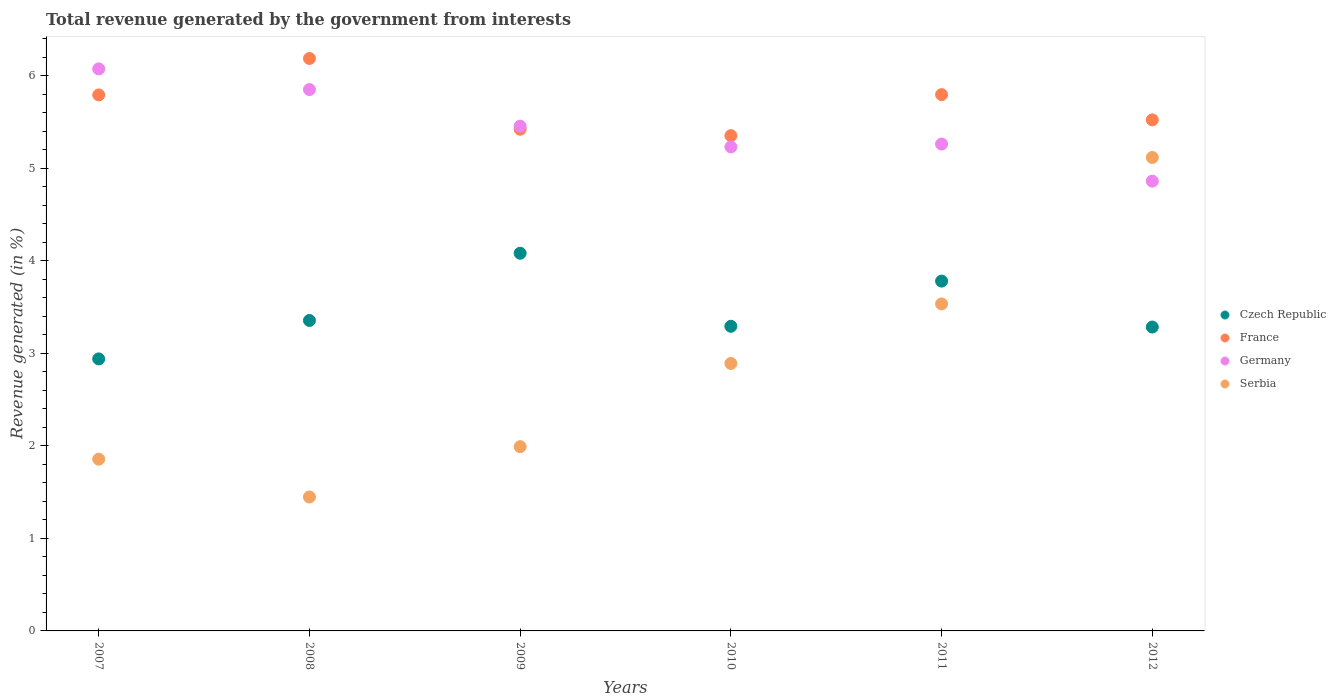How many different coloured dotlines are there?
Your answer should be very brief. 4. What is the total revenue generated in Czech Republic in 2010?
Offer a very short reply. 3.29. Across all years, what is the maximum total revenue generated in Germany?
Your response must be concise. 6.07. Across all years, what is the minimum total revenue generated in Czech Republic?
Your answer should be very brief. 2.94. In which year was the total revenue generated in Serbia maximum?
Your answer should be very brief. 2012. In which year was the total revenue generated in Serbia minimum?
Offer a terse response. 2008. What is the total total revenue generated in Serbia in the graph?
Offer a very short reply. 16.83. What is the difference between the total revenue generated in Germany in 2009 and that in 2011?
Your answer should be compact. 0.19. What is the difference between the total revenue generated in Germany in 2008 and the total revenue generated in Serbia in 2010?
Your answer should be very brief. 2.96. What is the average total revenue generated in Czech Republic per year?
Provide a short and direct response. 3.45. In the year 2009, what is the difference between the total revenue generated in Serbia and total revenue generated in France?
Keep it short and to the point. -3.43. In how many years, is the total revenue generated in Serbia greater than 2.8 %?
Offer a terse response. 3. What is the ratio of the total revenue generated in Germany in 2010 to that in 2012?
Your answer should be very brief. 1.08. What is the difference between the highest and the second highest total revenue generated in Serbia?
Provide a succinct answer. 1.58. What is the difference between the highest and the lowest total revenue generated in Czech Republic?
Offer a very short reply. 1.14. Is the sum of the total revenue generated in Czech Republic in 2008 and 2011 greater than the maximum total revenue generated in Germany across all years?
Your answer should be very brief. Yes. Is it the case that in every year, the sum of the total revenue generated in Germany and total revenue generated in Czech Republic  is greater than the total revenue generated in Serbia?
Offer a very short reply. Yes. Does the total revenue generated in France monotonically increase over the years?
Keep it short and to the point. No. Is the total revenue generated in Czech Republic strictly greater than the total revenue generated in France over the years?
Make the answer very short. No. How many years are there in the graph?
Provide a succinct answer. 6. What is the difference between two consecutive major ticks on the Y-axis?
Make the answer very short. 1. Are the values on the major ticks of Y-axis written in scientific E-notation?
Your answer should be compact. No. Where does the legend appear in the graph?
Your response must be concise. Center right. How many legend labels are there?
Your answer should be very brief. 4. What is the title of the graph?
Make the answer very short. Total revenue generated by the government from interests. Does "Paraguay" appear as one of the legend labels in the graph?
Your answer should be very brief. No. What is the label or title of the X-axis?
Provide a short and direct response. Years. What is the label or title of the Y-axis?
Ensure brevity in your answer.  Revenue generated (in %). What is the Revenue generated (in %) of Czech Republic in 2007?
Ensure brevity in your answer.  2.94. What is the Revenue generated (in %) in France in 2007?
Your response must be concise. 5.79. What is the Revenue generated (in %) in Germany in 2007?
Your response must be concise. 6.07. What is the Revenue generated (in %) of Serbia in 2007?
Give a very brief answer. 1.86. What is the Revenue generated (in %) in Czech Republic in 2008?
Ensure brevity in your answer.  3.35. What is the Revenue generated (in %) in France in 2008?
Your answer should be very brief. 6.18. What is the Revenue generated (in %) in Germany in 2008?
Your answer should be very brief. 5.85. What is the Revenue generated (in %) of Serbia in 2008?
Offer a very short reply. 1.45. What is the Revenue generated (in %) of Czech Republic in 2009?
Make the answer very short. 4.08. What is the Revenue generated (in %) of France in 2009?
Give a very brief answer. 5.42. What is the Revenue generated (in %) of Germany in 2009?
Offer a terse response. 5.45. What is the Revenue generated (in %) in Serbia in 2009?
Provide a succinct answer. 1.99. What is the Revenue generated (in %) of Czech Republic in 2010?
Offer a very short reply. 3.29. What is the Revenue generated (in %) of France in 2010?
Ensure brevity in your answer.  5.35. What is the Revenue generated (in %) in Germany in 2010?
Make the answer very short. 5.23. What is the Revenue generated (in %) in Serbia in 2010?
Ensure brevity in your answer.  2.89. What is the Revenue generated (in %) in Czech Republic in 2011?
Your response must be concise. 3.78. What is the Revenue generated (in %) in France in 2011?
Ensure brevity in your answer.  5.79. What is the Revenue generated (in %) of Germany in 2011?
Your response must be concise. 5.26. What is the Revenue generated (in %) in Serbia in 2011?
Ensure brevity in your answer.  3.53. What is the Revenue generated (in %) of Czech Republic in 2012?
Your answer should be compact. 3.28. What is the Revenue generated (in %) in France in 2012?
Your answer should be very brief. 5.52. What is the Revenue generated (in %) of Germany in 2012?
Make the answer very short. 4.86. What is the Revenue generated (in %) of Serbia in 2012?
Ensure brevity in your answer.  5.12. Across all years, what is the maximum Revenue generated (in %) in Czech Republic?
Ensure brevity in your answer.  4.08. Across all years, what is the maximum Revenue generated (in %) in France?
Give a very brief answer. 6.18. Across all years, what is the maximum Revenue generated (in %) of Germany?
Keep it short and to the point. 6.07. Across all years, what is the maximum Revenue generated (in %) in Serbia?
Provide a short and direct response. 5.12. Across all years, what is the minimum Revenue generated (in %) of Czech Republic?
Ensure brevity in your answer.  2.94. Across all years, what is the minimum Revenue generated (in %) in France?
Provide a succinct answer. 5.35. Across all years, what is the minimum Revenue generated (in %) of Germany?
Your answer should be very brief. 4.86. Across all years, what is the minimum Revenue generated (in %) of Serbia?
Keep it short and to the point. 1.45. What is the total Revenue generated (in %) of Czech Republic in the graph?
Your response must be concise. 20.73. What is the total Revenue generated (in %) of France in the graph?
Offer a very short reply. 34.06. What is the total Revenue generated (in %) of Germany in the graph?
Make the answer very short. 32.72. What is the total Revenue generated (in %) of Serbia in the graph?
Make the answer very short. 16.83. What is the difference between the Revenue generated (in %) in Czech Republic in 2007 and that in 2008?
Provide a short and direct response. -0.42. What is the difference between the Revenue generated (in %) of France in 2007 and that in 2008?
Keep it short and to the point. -0.39. What is the difference between the Revenue generated (in %) in Germany in 2007 and that in 2008?
Your response must be concise. 0.22. What is the difference between the Revenue generated (in %) of Serbia in 2007 and that in 2008?
Offer a very short reply. 0.41. What is the difference between the Revenue generated (in %) in Czech Republic in 2007 and that in 2009?
Your answer should be compact. -1.14. What is the difference between the Revenue generated (in %) of France in 2007 and that in 2009?
Your response must be concise. 0.37. What is the difference between the Revenue generated (in %) of Germany in 2007 and that in 2009?
Ensure brevity in your answer.  0.62. What is the difference between the Revenue generated (in %) of Serbia in 2007 and that in 2009?
Make the answer very short. -0.14. What is the difference between the Revenue generated (in %) in Czech Republic in 2007 and that in 2010?
Keep it short and to the point. -0.35. What is the difference between the Revenue generated (in %) of France in 2007 and that in 2010?
Your answer should be very brief. 0.44. What is the difference between the Revenue generated (in %) in Germany in 2007 and that in 2010?
Make the answer very short. 0.84. What is the difference between the Revenue generated (in %) in Serbia in 2007 and that in 2010?
Give a very brief answer. -1.03. What is the difference between the Revenue generated (in %) in Czech Republic in 2007 and that in 2011?
Offer a very short reply. -0.84. What is the difference between the Revenue generated (in %) in France in 2007 and that in 2011?
Give a very brief answer. -0. What is the difference between the Revenue generated (in %) in Germany in 2007 and that in 2011?
Make the answer very short. 0.81. What is the difference between the Revenue generated (in %) in Serbia in 2007 and that in 2011?
Make the answer very short. -1.68. What is the difference between the Revenue generated (in %) in Czech Republic in 2007 and that in 2012?
Offer a very short reply. -0.34. What is the difference between the Revenue generated (in %) of France in 2007 and that in 2012?
Offer a very short reply. 0.27. What is the difference between the Revenue generated (in %) of Germany in 2007 and that in 2012?
Make the answer very short. 1.21. What is the difference between the Revenue generated (in %) of Serbia in 2007 and that in 2012?
Make the answer very short. -3.26. What is the difference between the Revenue generated (in %) in Czech Republic in 2008 and that in 2009?
Offer a terse response. -0.73. What is the difference between the Revenue generated (in %) in France in 2008 and that in 2009?
Ensure brevity in your answer.  0.76. What is the difference between the Revenue generated (in %) of Germany in 2008 and that in 2009?
Your response must be concise. 0.4. What is the difference between the Revenue generated (in %) in Serbia in 2008 and that in 2009?
Keep it short and to the point. -0.54. What is the difference between the Revenue generated (in %) of Czech Republic in 2008 and that in 2010?
Your response must be concise. 0.06. What is the difference between the Revenue generated (in %) of France in 2008 and that in 2010?
Keep it short and to the point. 0.83. What is the difference between the Revenue generated (in %) in Germany in 2008 and that in 2010?
Offer a very short reply. 0.62. What is the difference between the Revenue generated (in %) of Serbia in 2008 and that in 2010?
Ensure brevity in your answer.  -1.44. What is the difference between the Revenue generated (in %) of Czech Republic in 2008 and that in 2011?
Give a very brief answer. -0.43. What is the difference between the Revenue generated (in %) in France in 2008 and that in 2011?
Give a very brief answer. 0.39. What is the difference between the Revenue generated (in %) of Germany in 2008 and that in 2011?
Ensure brevity in your answer.  0.59. What is the difference between the Revenue generated (in %) in Serbia in 2008 and that in 2011?
Your response must be concise. -2.09. What is the difference between the Revenue generated (in %) of Czech Republic in 2008 and that in 2012?
Offer a very short reply. 0.07. What is the difference between the Revenue generated (in %) in France in 2008 and that in 2012?
Give a very brief answer. 0.66. What is the difference between the Revenue generated (in %) of Germany in 2008 and that in 2012?
Offer a terse response. 0.99. What is the difference between the Revenue generated (in %) of Serbia in 2008 and that in 2012?
Provide a succinct answer. -3.67. What is the difference between the Revenue generated (in %) of Czech Republic in 2009 and that in 2010?
Keep it short and to the point. 0.79. What is the difference between the Revenue generated (in %) of France in 2009 and that in 2010?
Your answer should be compact. 0.07. What is the difference between the Revenue generated (in %) of Germany in 2009 and that in 2010?
Keep it short and to the point. 0.22. What is the difference between the Revenue generated (in %) of Serbia in 2009 and that in 2010?
Give a very brief answer. -0.9. What is the difference between the Revenue generated (in %) of Czech Republic in 2009 and that in 2011?
Provide a succinct answer. 0.3. What is the difference between the Revenue generated (in %) in France in 2009 and that in 2011?
Keep it short and to the point. -0.37. What is the difference between the Revenue generated (in %) in Germany in 2009 and that in 2011?
Provide a short and direct response. 0.19. What is the difference between the Revenue generated (in %) in Serbia in 2009 and that in 2011?
Your answer should be compact. -1.54. What is the difference between the Revenue generated (in %) of Czech Republic in 2009 and that in 2012?
Provide a succinct answer. 0.8. What is the difference between the Revenue generated (in %) in France in 2009 and that in 2012?
Your answer should be compact. -0.1. What is the difference between the Revenue generated (in %) in Germany in 2009 and that in 2012?
Your answer should be very brief. 0.59. What is the difference between the Revenue generated (in %) in Serbia in 2009 and that in 2012?
Your response must be concise. -3.12. What is the difference between the Revenue generated (in %) of Czech Republic in 2010 and that in 2011?
Your answer should be compact. -0.49. What is the difference between the Revenue generated (in %) of France in 2010 and that in 2011?
Offer a terse response. -0.44. What is the difference between the Revenue generated (in %) of Germany in 2010 and that in 2011?
Ensure brevity in your answer.  -0.03. What is the difference between the Revenue generated (in %) of Serbia in 2010 and that in 2011?
Offer a very short reply. -0.64. What is the difference between the Revenue generated (in %) in Czech Republic in 2010 and that in 2012?
Make the answer very short. 0.01. What is the difference between the Revenue generated (in %) of France in 2010 and that in 2012?
Provide a succinct answer. -0.17. What is the difference between the Revenue generated (in %) of Germany in 2010 and that in 2012?
Give a very brief answer. 0.37. What is the difference between the Revenue generated (in %) of Serbia in 2010 and that in 2012?
Your response must be concise. -2.23. What is the difference between the Revenue generated (in %) in Czech Republic in 2011 and that in 2012?
Your response must be concise. 0.5. What is the difference between the Revenue generated (in %) of France in 2011 and that in 2012?
Give a very brief answer. 0.27. What is the difference between the Revenue generated (in %) in Germany in 2011 and that in 2012?
Provide a succinct answer. 0.4. What is the difference between the Revenue generated (in %) of Serbia in 2011 and that in 2012?
Provide a short and direct response. -1.58. What is the difference between the Revenue generated (in %) of Czech Republic in 2007 and the Revenue generated (in %) of France in 2008?
Offer a very short reply. -3.25. What is the difference between the Revenue generated (in %) of Czech Republic in 2007 and the Revenue generated (in %) of Germany in 2008?
Provide a short and direct response. -2.91. What is the difference between the Revenue generated (in %) of Czech Republic in 2007 and the Revenue generated (in %) of Serbia in 2008?
Make the answer very short. 1.49. What is the difference between the Revenue generated (in %) in France in 2007 and the Revenue generated (in %) in Germany in 2008?
Give a very brief answer. -0.06. What is the difference between the Revenue generated (in %) in France in 2007 and the Revenue generated (in %) in Serbia in 2008?
Make the answer very short. 4.34. What is the difference between the Revenue generated (in %) of Germany in 2007 and the Revenue generated (in %) of Serbia in 2008?
Provide a succinct answer. 4.63. What is the difference between the Revenue generated (in %) in Czech Republic in 2007 and the Revenue generated (in %) in France in 2009?
Your response must be concise. -2.48. What is the difference between the Revenue generated (in %) of Czech Republic in 2007 and the Revenue generated (in %) of Germany in 2009?
Make the answer very short. -2.51. What is the difference between the Revenue generated (in %) in Czech Republic in 2007 and the Revenue generated (in %) in Serbia in 2009?
Provide a short and direct response. 0.95. What is the difference between the Revenue generated (in %) of France in 2007 and the Revenue generated (in %) of Germany in 2009?
Give a very brief answer. 0.34. What is the difference between the Revenue generated (in %) of France in 2007 and the Revenue generated (in %) of Serbia in 2009?
Keep it short and to the point. 3.8. What is the difference between the Revenue generated (in %) in Germany in 2007 and the Revenue generated (in %) in Serbia in 2009?
Make the answer very short. 4.08. What is the difference between the Revenue generated (in %) in Czech Republic in 2007 and the Revenue generated (in %) in France in 2010?
Give a very brief answer. -2.41. What is the difference between the Revenue generated (in %) of Czech Republic in 2007 and the Revenue generated (in %) of Germany in 2010?
Your answer should be very brief. -2.29. What is the difference between the Revenue generated (in %) of Czech Republic in 2007 and the Revenue generated (in %) of Serbia in 2010?
Keep it short and to the point. 0.05. What is the difference between the Revenue generated (in %) in France in 2007 and the Revenue generated (in %) in Germany in 2010?
Your answer should be compact. 0.56. What is the difference between the Revenue generated (in %) of France in 2007 and the Revenue generated (in %) of Serbia in 2010?
Give a very brief answer. 2.9. What is the difference between the Revenue generated (in %) of Germany in 2007 and the Revenue generated (in %) of Serbia in 2010?
Your answer should be compact. 3.18. What is the difference between the Revenue generated (in %) of Czech Republic in 2007 and the Revenue generated (in %) of France in 2011?
Offer a terse response. -2.86. What is the difference between the Revenue generated (in %) in Czech Republic in 2007 and the Revenue generated (in %) in Germany in 2011?
Keep it short and to the point. -2.32. What is the difference between the Revenue generated (in %) in Czech Republic in 2007 and the Revenue generated (in %) in Serbia in 2011?
Make the answer very short. -0.59. What is the difference between the Revenue generated (in %) of France in 2007 and the Revenue generated (in %) of Germany in 2011?
Make the answer very short. 0.53. What is the difference between the Revenue generated (in %) of France in 2007 and the Revenue generated (in %) of Serbia in 2011?
Provide a succinct answer. 2.26. What is the difference between the Revenue generated (in %) of Germany in 2007 and the Revenue generated (in %) of Serbia in 2011?
Keep it short and to the point. 2.54. What is the difference between the Revenue generated (in %) in Czech Republic in 2007 and the Revenue generated (in %) in France in 2012?
Provide a short and direct response. -2.58. What is the difference between the Revenue generated (in %) in Czech Republic in 2007 and the Revenue generated (in %) in Germany in 2012?
Give a very brief answer. -1.92. What is the difference between the Revenue generated (in %) of Czech Republic in 2007 and the Revenue generated (in %) of Serbia in 2012?
Your response must be concise. -2.18. What is the difference between the Revenue generated (in %) of France in 2007 and the Revenue generated (in %) of Germany in 2012?
Keep it short and to the point. 0.93. What is the difference between the Revenue generated (in %) in France in 2007 and the Revenue generated (in %) in Serbia in 2012?
Ensure brevity in your answer.  0.68. What is the difference between the Revenue generated (in %) of Germany in 2007 and the Revenue generated (in %) of Serbia in 2012?
Ensure brevity in your answer.  0.96. What is the difference between the Revenue generated (in %) in Czech Republic in 2008 and the Revenue generated (in %) in France in 2009?
Ensure brevity in your answer.  -2.07. What is the difference between the Revenue generated (in %) in Czech Republic in 2008 and the Revenue generated (in %) in Germany in 2009?
Make the answer very short. -2.1. What is the difference between the Revenue generated (in %) in Czech Republic in 2008 and the Revenue generated (in %) in Serbia in 2009?
Keep it short and to the point. 1.36. What is the difference between the Revenue generated (in %) of France in 2008 and the Revenue generated (in %) of Germany in 2009?
Your answer should be very brief. 0.73. What is the difference between the Revenue generated (in %) in France in 2008 and the Revenue generated (in %) in Serbia in 2009?
Provide a succinct answer. 4.19. What is the difference between the Revenue generated (in %) of Germany in 2008 and the Revenue generated (in %) of Serbia in 2009?
Give a very brief answer. 3.86. What is the difference between the Revenue generated (in %) of Czech Republic in 2008 and the Revenue generated (in %) of France in 2010?
Provide a succinct answer. -2. What is the difference between the Revenue generated (in %) in Czech Republic in 2008 and the Revenue generated (in %) in Germany in 2010?
Your answer should be very brief. -1.88. What is the difference between the Revenue generated (in %) in Czech Republic in 2008 and the Revenue generated (in %) in Serbia in 2010?
Make the answer very short. 0.46. What is the difference between the Revenue generated (in %) in France in 2008 and the Revenue generated (in %) in Germany in 2010?
Your answer should be compact. 0.96. What is the difference between the Revenue generated (in %) in France in 2008 and the Revenue generated (in %) in Serbia in 2010?
Your answer should be compact. 3.29. What is the difference between the Revenue generated (in %) of Germany in 2008 and the Revenue generated (in %) of Serbia in 2010?
Keep it short and to the point. 2.96. What is the difference between the Revenue generated (in %) in Czech Republic in 2008 and the Revenue generated (in %) in France in 2011?
Ensure brevity in your answer.  -2.44. What is the difference between the Revenue generated (in %) of Czech Republic in 2008 and the Revenue generated (in %) of Germany in 2011?
Keep it short and to the point. -1.91. What is the difference between the Revenue generated (in %) of Czech Republic in 2008 and the Revenue generated (in %) of Serbia in 2011?
Offer a very short reply. -0.18. What is the difference between the Revenue generated (in %) in France in 2008 and the Revenue generated (in %) in Germany in 2011?
Your response must be concise. 0.92. What is the difference between the Revenue generated (in %) in France in 2008 and the Revenue generated (in %) in Serbia in 2011?
Offer a very short reply. 2.65. What is the difference between the Revenue generated (in %) in Germany in 2008 and the Revenue generated (in %) in Serbia in 2011?
Provide a succinct answer. 2.32. What is the difference between the Revenue generated (in %) of Czech Republic in 2008 and the Revenue generated (in %) of France in 2012?
Provide a succinct answer. -2.17. What is the difference between the Revenue generated (in %) of Czech Republic in 2008 and the Revenue generated (in %) of Germany in 2012?
Your answer should be very brief. -1.51. What is the difference between the Revenue generated (in %) of Czech Republic in 2008 and the Revenue generated (in %) of Serbia in 2012?
Make the answer very short. -1.76. What is the difference between the Revenue generated (in %) in France in 2008 and the Revenue generated (in %) in Germany in 2012?
Provide a short and direct response. 1.33. What is the difference between the Revenue generated (in %) in France in 2008 and the Revenue generated (in %) in Serbia in 2012?
Your answer should be compact. 1.07. What is the difference between the Revenue generated (in %) of Germany in 2008 and the Revenue generated (in %) of Serbia in 2012?
Your answer should be very brief. 0.73. What is the difference between the Revenue generated (in %) of Czech Republic in 2009 and the Revenue generated (in %) of France in 2010?
Your answer should be very brief. -1.27. What is the difference between the Revenue generated (in %) of Czech Republic in 2009 and the Revenue generated (in %) of Germany in 2010?
Your answer should be very brief. -1.15. What is the difference between the Revenue generated (in %) in Czech Republic in 2009 and the Revenue generated (in %) in Serbia in 2010?
Your response must be concise. 1.19. What is the difference between the Revenue generated (in %) in France in 2009 and the Revenue generated (in %) in Germany in 2010?
Your answer should be very brief. 0.19. What is the difference between the Revenue generated (in %) of France in 2009 and the Revenue generated (in %) of Serbia in 2010?
Give a very brief answer. 2.53. What is the difference between the Revenue generated (in %) in Germany in 2009 and the Revenue generated (in %) in Serbia in 2010?
Make the answer very short. 2.56. What is the difference between the Revenue generated (in %) of Czech Republic in 2009 and the Revenue generated (in %) of France in 2011?
Make the answer very short. -1.71. What is the difference between the Revenue generated (in %) of Czech Republic in 2009 and the Revenue generated (in %) of Germany in 2011?
Provide a succinct answer. -1.18. What is the difference between the Revenue generated (in %) in Czech Republic in 2009 and the Revenue generated (in %) in Serbia in 2011?
Your answer should be very brief. 0.55. What is the difference between the Revenue generated (in %) in France in 2009 and the Revenue generated (in %) in Germany in 2011?
Provide a succinct answer. 0.16. What is the difference between the Revenue generated (in %) of France in 2009 and the Revenue generated (in %) of Serbia in 2011?
Ensure brevity in your answer.  1.89. What is the difference between the Revenue generated (in %) of Germany in 2009 and the Revenue generated (in %) of Serbia in 2011?
Keep it short and to the point. 1.92. What is the difference between the Revenue generated (in %) of Czech Republic in 2009 and the Revenue generated (in %) of France in 2012?
Your answer should be compact. -1.44. What is the difference between the Revenue generated (in %) in Czech Republic in 2009 and the Revenue generated (in %) in Germany in 2012?
Provide a succinct answer. -0.78. What is the difference between the Revenue generated (in %) of Czech Republic in 2009 and the Revenue generated (in %) of Serbia in 2012?
Provide a short and direct response. -1.03. What is the difference between the Revenue generated (in %) in France in 2009 and the Revenue generated (in %) in Germany in 2012?
Give a very brief answer. 0.56. What is the difference between the Revenue generated (in %) in France in 2009 and the Revenue generated (in %) in Serbia in 2012?
Offer a terse response. 0.31. What is the difference between the Revenue generated (in %) in Germany in 2009 and the Revenue generated (in %) in Serbia in 2012?
Your response must be concise. 0.34. What is the difference between the Revenue generated (in %) in Czech Republic in 2010 and the Revenue generated (in %) in France in 2011?
Your response must be concise. -2.5. What is the difference between the Revenue generated (in %) of Czech Republic in 2010 and the Revenue generated (in %) of Germany in 2011?
Provide a succinct answer. -1.97. What is the difference between the Revenue generated (in %) in Czech Republic in 2010 and the Revenue generated (in %) in Serbia in 2011?
Keep it short and to the point. -0.24. What is the difference between the Revenue generated (in %) in France in 2010 and the Revenue generated (in %) in Germany in 2011?
Your response must be concise. 0.09. What is the difference between the Revenue generated (in %) of France in 2010 and the Revenue generated (in %) of Serbia in 2011?
Provide a short and direct response. 1.82. What is the difference between the Revenue generated (in %) of Germany in 2010 and the Revenue generated (in %) of Serbia in 2011?
Give a very brief answer. 1.7. What is the difference between the Revenue generated (in %) in Czech Republic in 2010 and the Revenue generated (in %) in France in 2012?
Provide a short and direct response. -2.23. What is the difference between the Revenue generated (in %) in Czech Republic in 2010 and the Revenue generated (in %) in Germany in 2012?
Provide a short and direct response. -1.57. What is the difference between the Revenue generated (in %) in Czech Republic in 2010 and the Revenue generated (in %) in Serbia in 2012?
Provide a succinct answer. -1.82. What is the difference between the Revenue generated (in %) in France in 2010 and the Revenue generated (in %) in Germany in 2012?
Provide a succinct answer. 0.49. What is the difference between the Revenue generated (in %) in France in 2010 and the Revenue generated (in %) in Serbia in 2012?
Your response must be concise. 0.24. What is the difference between the Revenue generated (in %) of Germany in 2010 and the Revenue generated (in %) of Serbia in 2012?
Offer a terse response. 0.11. What is the difference between the Revenue generated (in %) in Czech Republic in 2011 and the Revenue generated (in %) in France in 2012?
Offer a very short reply. -1.74. What is the difference between the Revenue generated (in %) of Czech Republic in 2011 and the Revenue generated (in %) of Germany in 2012?
Your answer should be very brief. -1.08. What is the difference between the Revenue generated (in %) in Czech Republic in 2011 and the Revenue generated (in %) in Serbia in 2012?
Your answer should be compact. -1.34. What is the difference between the Revenue generated (in %) of France in 2011 and the Revenue generated (in %) of Germany in 2012?
Provide a succinct answer. 0.93. What is the difference between the Revenue generated (in %) of France in 2011 and the Revenue generated (in %) of Serbia in 2012?
Offer a very short reply. 0.68. What is the difference between the Revenue generated (in %) of Germany in 2011 and the Revenue generated (in %) of Serbia in 2012?
Your answer should be very brief. 0.14. What is the average Revenue generated (in %) of Czech Republic per year?
Offer a very short reply. 3.45. What is the average Revenue generated (in %) in France per year?
Your response must be concise. 5.68. What is the average Revenue generated (in %) of Germany per year?
Your answer should be compact. 5.45. What is the average Revenue generated (in %) in Serbia per year?
Your answer should be compact. 2.81. In the year 2007, what is the difference between the Revenue generated (in %) in Czech Republic and Revenue generated (in %) in France?
Provide a succinct answer. -2.85. In the year 2007, what is the difference between the Revenue generated (in %) of Czech Republic and Revenue generated (in %) of Germany?
Give a very brief answer. -3.13. In the year 2007, what is the difference between the Revenue generated (in %) of Czech Republic and Revenue generated (in %) of Serbia?
Your response must be concise. 1.08. In the year 2007, what is the difference between the Revenue generated (in %) in France and Revenue generated (in %) in Germany?
Ensure brevity in your answer.  -0.28. In the year 2007, what is the difference between the Revenue generated (in %) of France and Revenue generated (in %) of Serbia?
Provide a short and direct response. 3.94. In the year 2007, what is the difference between the Revenue generated (in %) of Germany and Revenue generated (in %) of Serbia?
Offer a terse response. 4.22. In the year 2008, what is the difference between the Revenue generated (in %) in Czech Republic and Revenue generated (in %) in France?
Offer a terse response. -2.83. In the year 2008, what is the difference between the Revenue generated (in %) of Czech Republic and Revenue generated (in %) of Germany?
Make the answer very short. -2.49. In the year 2008, what is the difference between the Revenue generated (in %) of Czech Republic and Revenue generated (in %) of Serbia?
Make the answer very short. 1.91. In the year 2008, what is the difference between the Revenue generated (in %) of France and Revenue generated (in %) of Germany?
Make the answer very short. 0.34. In the year 2008, what is the difference between the Revenue generated (in %) in France and Revenue generated (in %) in Serbia?
Your answer should be compact. 4.74. In the year 2008, what is the difference between the Revenue generated (in %) in Germany and Revenue generated (in %) in Serbia?
Your answer should be compact. 4.4. In the year 2009, what is the difference between the Revenue generated (in %) of Czech Republic and Revenue generated (in %) of France?
Provide a succinct answer. -1.34. In the year 2009, what is the difference between the Revenue generated (in %) of Czech Republic and Revenue generated (in %) of Germany?
Ensure brevity in your answer.  -1.37. In the year 2009, what is the difference between the Revenue generated (in %) of Czech Republic and Revenue generated (in %) of Serbia?
Your answer should be very brief. 2.09. In the year 2009, what is the difference between the Revenue generated (in %) of France and Revenue generated (in %) of Germany?
Provide a short and direct response. -0.03. In the year 2009, what is the difference between the Revenue generated (in %) of France and Revenue generated (in %) of Serbia?
Your answer should be compact. 3.43. In the year 2009, what is the difference between the Revenue generated (in %) of Germany and Revenue generated (in %) of Serbia?
Provide a succinct answer. 3.46. In the year 2010, what is the difference between the Revenue generated (in %) of Czech Republic and Revenue generated (in %) of France?
Keep it short and to the point. -2.06. In the year 2010, what is the difference between the Revenue generated (in %) in Czech Republic and Revenue generated (in %) in Germany?
Provide a succinct answer. -1.94. In the year 2010, what is the difference between the Revenue generated (in %) in Czech Republic and Revenue generated (in %) in Serbia?
Provide a short and direct response. 0.4. In the year 2010, what is the difference between the Revenue generated (in %) in France and Revenue generated (in %) in Germany?
Keep it short and to the point. 0.12. In the year 2010, what is the difference between the Revenue generated (in %) of France and Revenue generated (in %) of Serbia?
Keep it short and to the point. 2.46. In the year 2010, what is the difference between the Revenue generated (in %) in Germany and Revenue generated (in %) in Serbia?
Provide a short and direct response. 2.34. In the year 2011, what is the difference between the Revenue generated (in %) of Czech Republic and Revenue generated (in %) of France?
Provide a succinct answer. -2.01. In the year 2011, what is the difference between the Revenue generated (in %) in Czech Republic and Revenue generated (in %) in Germany?
Provide a short and direct response. -1.48. In the year 2011, what is the difference between the Revenue generated (in %) of Czech Republic and Revenue generated (in %) of Serbia?
Your response must be concise. 0.25. In the year 2011, what is the difference between the Revenue generated (in %) of France and Revenue generated (in %) of Germany?
Give a very brief answer. 0.53. In the year 2011, what is the difference between the Revenue generated (in %) in France and Revenue generated (in %) in Serbia?
Offer a terse response. 2.26. In the year 2011, what is the difference between the Revenue generated (in %) of Germany and Revenue generated (in %) of Serbia?
Give a very brief answer. 1.73. In the year 2012, what is the difference between the Revenue generated (in %) of Czech Republic and Revenue generated (in %) of France?
Give a very brief answer. -2.24. In the year 2012, what is the difference between the Revenue generated (in %) of Czech Republic and Revenue generated (in %) of Germany?
Offer a terse response. -1.58. In the year 2012, what is the difference between the Revenue generated (in %) in Czech Republic and Revenue generated (in %) in Serbia?
Provide a short and direct response. -1.83. In the year 2012, what is the difference between the Revenue generated (in %) in France and Revenue generated (in %) in Germany?
Offer a terse response. 0.66. In the year 2012, what is the difference between the Revenue generated (in %) of France and Revenue generated (in %) of Serbia?
Keep it short and to the point. 0.41. In the year 2012, what is the difference between the Revenue generated (in %) in Germany and Revenue generated (in %) in Serbia?
Provide a succinct answer. -0.26. What is the ratio of the Revenue generated (in %) in Czech Republic in 2007 to that in 2008?
Your answer should be compact. 0.88. What is the ratio of the Revenue generated (in %) of France in 2007 to that in 2008?
Keep it short and to the point. 0.94. What is the ratio of the Revenue generated (in %) in Germany in 2007 to that in 2008?
Give a very brief answer. 1.04. What is the ratio of the Revenue generated (in %) in Serbia in 2007 to that in 2008?
Your answer should be very brief. 1.28. What is the ratio of the Revenue generated (in %) of Czech Republic in 2007 to that in 2009?
Make the answer very short. 0.72. What is the ratio of the Revenue generated (in %) of France in 2007 to that in 2009?
Offer a very short reply. 1.07. What is the ratio of the Revenue generated (in %) of Germany in 2007 to that in 2009?
Ensure brevity in your answer.  1.11. What is the ratio of the Revenue generated (in %) of Serbia in 2007 to that in 2009?
Your answer should be very brief. 0.93. What is the ratio of the Revenue generated (in %) of Czech Republic in 2007 to that in 2010?
Your response must be concise. 0.89. What is the ratio of the Revenue generated (in %) of France in 2007 to that in 2010?
Provide a short and direct response. 1.08. What is the ratio of the Revenue generated (in %) of Germany in 2007 to that in 2010?
Give a very brief answer. 1.16. What is the ratio of the Revenue generated (in %) of Serbia in 2007 to that in 2010?
Offer a terse response. 0.64. What is the ratio of the Revenue generated (in %) of Czech Republic in 2007 to that in 2011?
Provide a succinct answer. 0.78. What is the ratio of the Revenue generated (in %) of France in 2007 to that in 2011?
Offer a very short reply. 1. What is the ratio of the Revenue generated (in %) in Germany in 2007 to that in 2011?
Make the answer very short. 1.15. What is the ratio of the Revenue generated (in %) in Serbia in 2007 to that in 2011?
Your answer should be very brief. 0.53. What is the ratio of the Revenue generated (in %) in Czech Republic in 2007 to that in 2012?
Provide a short and direct response. 0.9. What is the ratio of the Revenue generated (in %) of France in 2007 to that in 2012?
Provide a succinct answer. 1.05. What is the ratio of the Revenue generated (in %) in Germany in 2007 to that in 2012?
Provide a short and direct response. 1.25. What is the ratio of the Revenue generated (in %) in Serbia in 2007 to that in 2012?
Ensure brevity in your answer.  0.36. What is the ratio of the Revenue generated (in %) of Czech Republic in 2008 to that in 2009?
Keep it short and to the point. 0.82. What is the ratio of the Revenue generated (in %) of France in 2008 to that in 2009?
Offer a terse response. 1.14. What is the ratio of the Revenue generated (in %) in Germany in 2008 to that in 2009?
Ensure brevity in your answer.  1.07. What is the ratio of the Revenue generated (in %) in Serbia in 2008 to that in 2009?
Your answer should be compact. 0.73. What is the ratio of the Revenue generated (in %) of Czech Republic in 2008 to that in 2010?
Give a very brief answer. 1.02. What is the ratio of the Revenue generated (in %) of France in 2008 to that in 2010?
Offer a very short reply. 1.16. What is the ratio of the Revenue generated (in %) of Germany in 2008 to that in 2010?
Ensure brevity in your answer.  1.12. What is the ratio of the Revenue generated (in %) in Serbia in 2008 to that in 2010?
Make the answer very short. 0.5. What is the ratio of the Revenue generated (in %) of Czech Republic in 2008 to that in 2011?
Ensure brevity in your answer.  0.89. What is the ratio of the Revenue generated (in %) of France in 2008 to that in 2011?
Your answer should be compact. 1.07. What is the ratio of the Revenue generated (in %) of Germany in 2008 to that in 2011?
Ensure brevity in your answer.  1.11. What is the ratio of the Revenue generated (in %) in Serbia in 2008 to that in 2011?
Offer a very short reply. 0.41. What is the ratio of the Revenue generated (in %) of Czech Republic in 2008 to that in 2012?
Provide a short and direct response. 1.02. What is the ratio of the Revenue generated (in %) of France in 2008 to that in 2012?
Keep it short and to the point. 1.12. What is the ratio of the Revenue generated (in %) of Germany in 2008 to that in 2012?
Provide a succinct answer. 1.2. What is the ratio of the Revenue generated (in %) of Serbia in 2008 to that in 2012?
Offer a very short reply. 0.28. What is the ratio of the Revenue generated (in %) in Czech Republic in 2009 to that in 2010?
Your answer should be very brief. 1.24. What is the ratio of the Revenue generated (in %) of France in 2009 to that in 2010?
Offer a very short reply. 1.01. What is the ratio of the Revenue generated (in %) of Germany in 2009 to that in 2010?
Make the answer very short. 1.04. What is the ratio of the Revenue generated (in %) of Serbia in 2009 to that in 2010?
Make the answer very short. 0.69. What is the ratio of the Revenue generated (in %) in Czech Republic in 2009 to that in 2011?
Your answer should be very brief. 1.08. What is the ratio of the Revenue generated (in %) in France in 2009 to that in 2011?
Give a very brief answer. 0.94. What is the ratio of the Revenue generated (in %) of Germany in 2009 to that in 2011?
Your answer should be very brief. 1.04. What is the ratio of the Revenue generated (in %) of Serbia in 2009 to that in 2011?
Your answer should be compact. 0.56. What is the ratio of the Revenue generated (in %) in Czech Republic in 2009 to that in 2012?
Provide a succinct answer. 1.24. What is the ratio of the Revenue generated (in %) of France in 2009 to that in 2012?
Ensure brevity in your answer.  0.98. What is the ratio of the Revenue generated (in %) in Germany in 2009 to that in 2012?
Provide a short and direct response. 1.12. What is the ratio of the Revenue generated (in %) in Serbia in 2009 to that in 2012?
Keep it short and to the point. 0.39. What is the ratio of the Revenue generated (in %) in Czech Republic in 2010 to that in 2011?
Keep it short and to the point. 0.87. What is the ratio of the Revenue generated (in %) of France in 2010 to that in 2011?
Make the answer very short. 0.92. What is the ratio of the Revenue generated (in %) in Germany in 2010 to that in 2011?
Give a very brief answer. 0.99. What is the ratio of the Revenue generated (in %) in Serbia in 2010 to that in 2011?
Offer a very short reply. 0.82. What is the ratio of the Revenue generated (in %) of Czech Republic in 2010 to that in 2012?
Provide a succinct answer. 1. What is the ratio of the Revenue generated (in %) in France in 2010 to that in 2012?
Give a very brief answer. 0.97. What is the ratio of the Revenue generated (in %) in Germany in 2010 to that in 2012?
Keep it short and to the point. 1.08. What is the ratio of the Revenue generated (in %) of Serbia in 2010 to that in 2012?
Make the answer very short. 0.56. What is the ratio of the Revenue generated (in %) in Czech Republic in 2011 to that in 2012?
Your answer should be compact. 1.15. What is the ratio of the Revenue generated (in %) in France in 2011 to that in 2012?
Ensure brevity in your answer.  1.05. What is the ratio of the Revenue generated (in %) of Germany in 2011 to that in 2012?
Ensure brevity in your answer.  1.08. What is the ratio of the Revenue generated (in %) in Serbia in 2011 to that in 2012?
Give a very brief answer. 0.69. What is the difference between the highest and the second highest Revenue generated (in %) in Czech Republic?
Offer a very short reply. 0.3. What is the difference between the highest and the second highest Revenue generated (in %) of France?
Keep it short and to the point. 0.39. What is the difference between the highest and the second highest Revenue generated (in %) in Germany?
Provide a succinct answer. 0.22. What is the difference between the highest and the second highest Revenue generated (in %) of Serbia?
Your response must be concise. 1.58. What is the difference between the highest and the lowest Revenue generated (in %) of Czech Republic?
Make the answer very short. 1.14. What is the difference between the highest and the lowest Revenue generated (in %) of France?
Give a very brief answer. 0.83. What is the difference between the highest and the lowest Revenue generated (in %) of Germany?
Give a very brief answer. 1.21. What is the difference between the highest and the lowest Revenue generated (in %) in Serbia?
Ensure brevity in your answer.  3.67. 